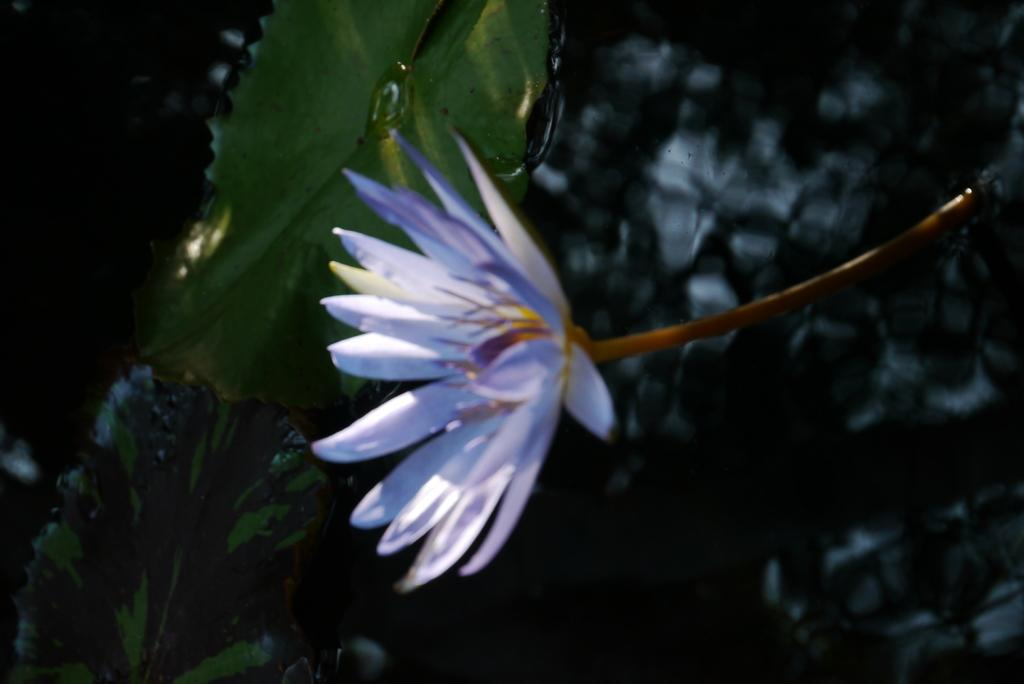What type of flower is in the image? There is a purple flower in the image. Where is the flower located? The flower is in the water. What else can be seen in the image related to the flower? There is a leaf behind the flower. How many pies are floating next to the flower in the image? There are no pies present in the image; it only features a purple flower in the water and a leaf behind it. 